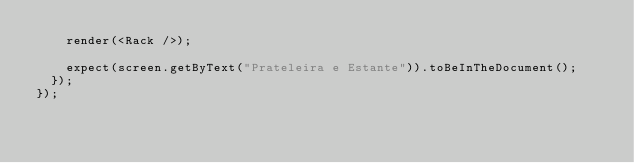Convert code to text. <code><loc_0><loc_0><loc_500><loc_500><_JavaScript_>		render(<Rack />);

		expect(screen.getByText("Prateleira e Estante")).toBeInTheDocument();
	});
});
</code> 